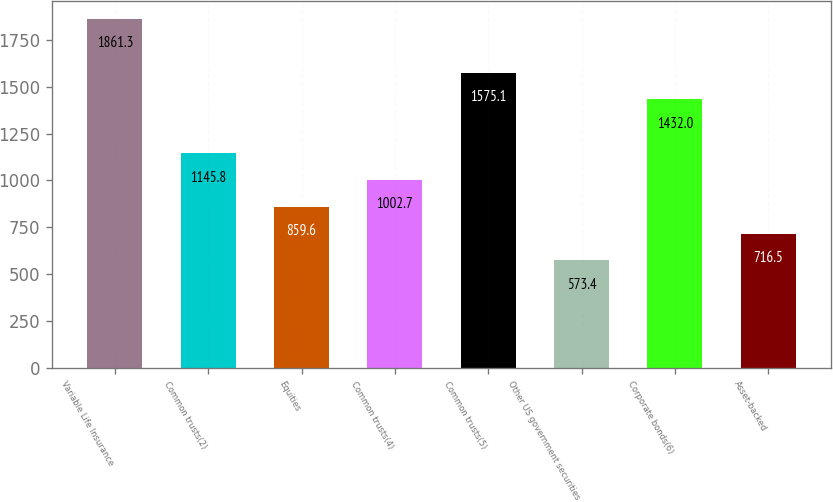<chart> <loc_0><loc_0><loc_500><loc_500><bar_chart><fcel>Variable Life Insurance<fcel>Common trusts(2)<fcel>Equities<fcel>Common trusts(4)<fcel>Common trusts(5)<fcel>Other US government securities<fcel>Corporate bonds(6)<fcel>Asset-backed<nl><fcel>1861.3<fcel>1145.8<fcel>859.6<fcel>1002.7<fcel>1575.1<fcel>573.4<fcel>1432<fcel>716.5<nl></chart> 